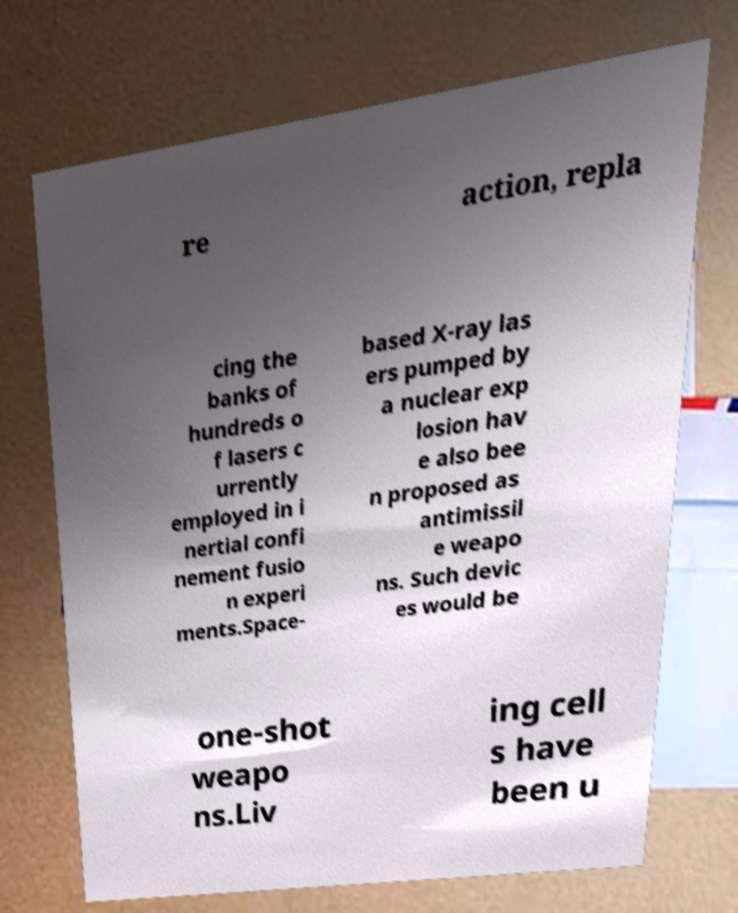Could you extract and type out the text from this image? re action, repla cing the banks of hundreds o f lasers c urrently employed in i nertial confi nement fusio n experi ments.Space- based X-ray las ers pumped by a nuclear exp losion hav e also bee n proposed as antimissil e weapo ns. Such devic es would be one-shot weapo ns.Liv ing cell s have been u 